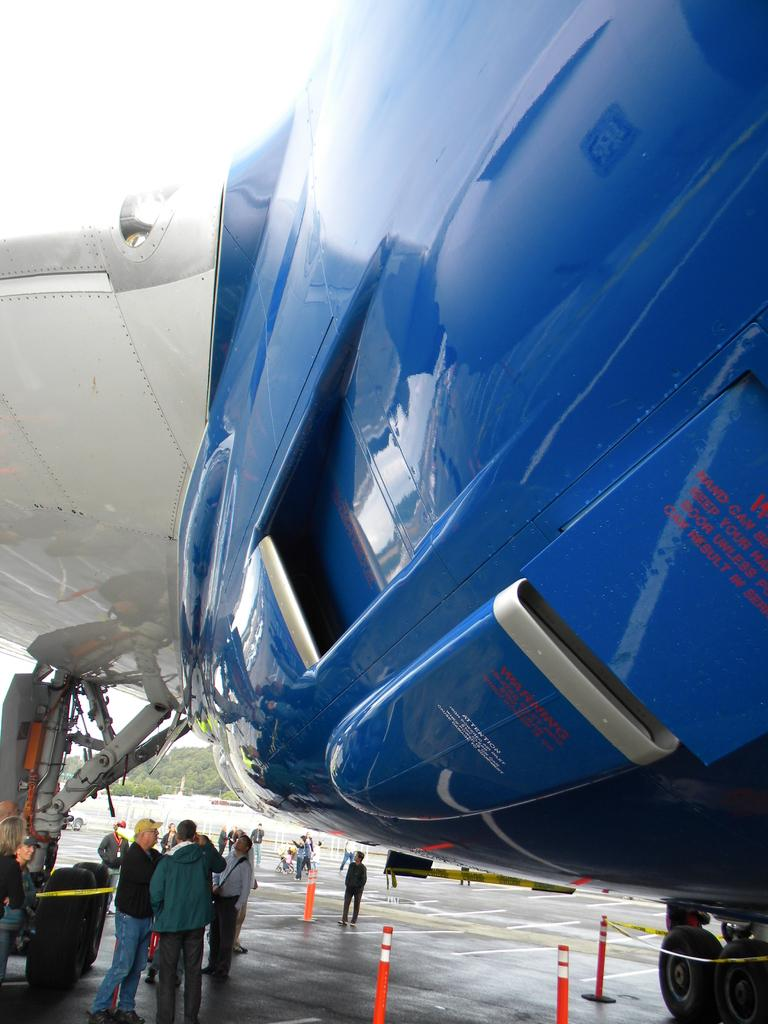What is the main subject of the image? The main subject of the image is an airplane. Can you describe the colors of the airplane? The airplane is blue and white in color. What other person can be seen in the image besides the airplane passengers? There is a traffic police in the image. What might be used to restrict access or warn people in the image? Caution tapes are present in the image. Are there any people visible in the image? Yes, there are people standing in the image. What other objects can be seen in the image? There are other objects in the image, but their specific details are not mentioned in the provided facts. Where is the zoo located in the image? There is no zoo present in the image. What type of currency is being used in the image? The provided facts do not mention any currency or financial transactions, so it cannot be determined from the image. 